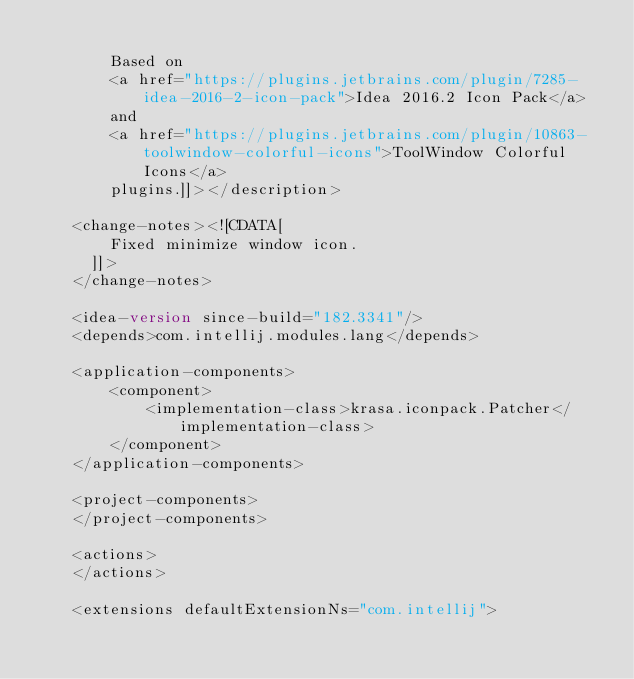Convert code to text. <code><loc_0><loc_0><loc_500><loc_500><_XML_>        
        Based on 
        <a href="https://plugins.jetbrains.com/plugin/7285-idea-2016-2-icon-pack">Idea 2016.2 Icon Pack</a> 
        and 
        <a href="https://plugins.jetbrains.com/plugin/10863-toolwindow-colorful-icons">ToolWindow Colorful Icons</a> 
        plugins.]]></description>

    <change-notes><![CDATA[
        Fixed minimize window icon.
      ]]>
    </change-notes>

    <idea-version since-build="182.3341"/>
    <depends>com.intellij.modules.lang</depends>

    <application-components>
        <component>
            <implementation-class>krasa.iconpack.Patcher</implementation-class>
        </component>
    </application-components>

    <project-components>
    </project-components>

    <actions>
    </actions>

    <extensions defaultExtensionNs="com.intellij"></code> 